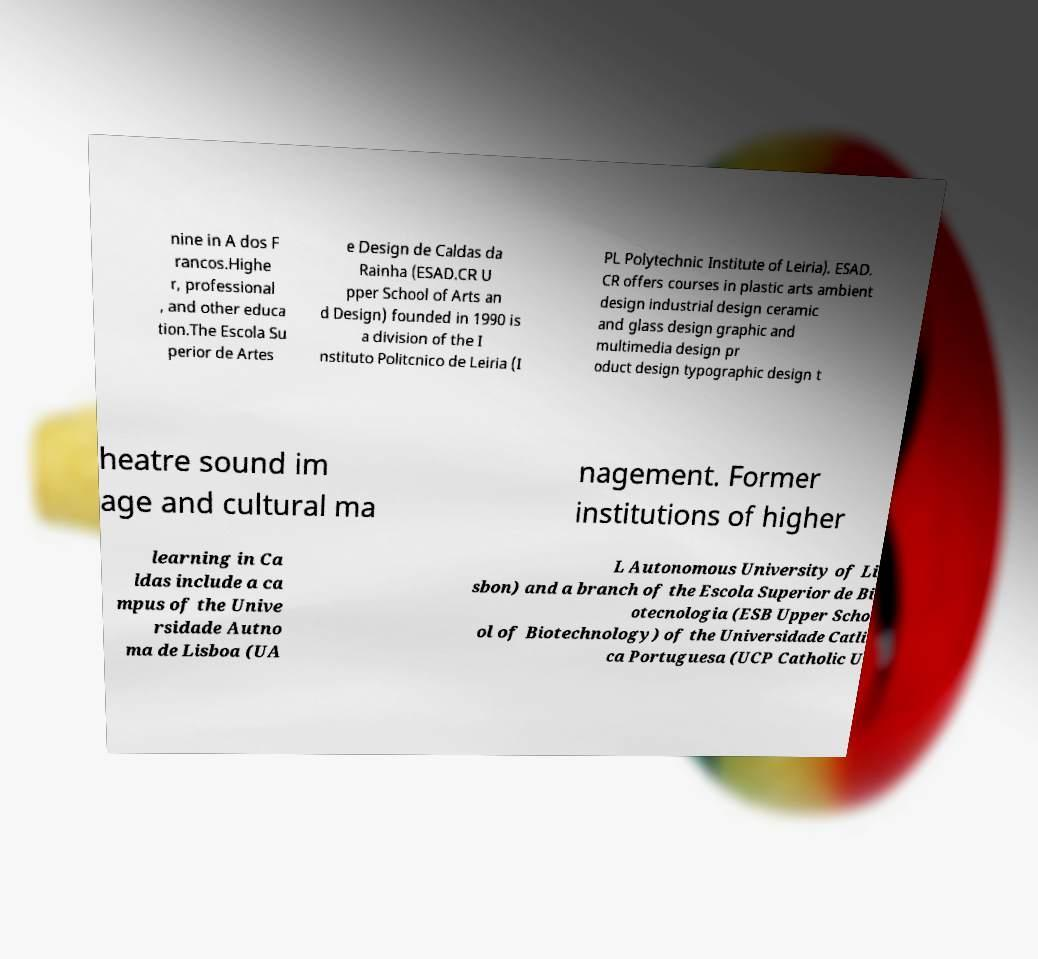Please read and relay the text visible in this image. What does it say? nine in A dos F rancos.Highe r, professional , and other educa tion.The Escola Su perior de Artes e Design de Caldas da Rainha (ESAD.CR U pper School of Arts an d Design) founded in 1990 is a division of the I nstituto Politcnico de Leiria (I PL Polytechnic Institute of Leiria). ESAD. CR offers courses in plastic arts ambient design industrial design ceramic and glass design graphic and multimedia design pr oduct design typographic design t heatre sound im age and cultural ma nagement. Former institutions of higher learning in Ca ldas include a ca mpus of the Unive rsidade Autno ma de Lisboa (UA L Autonomous University of Li sbon) and a branch of the Escola Superior de Bi otecnologia (ESB Upper Scho ol of Biotechnology) of the Universidade Catli ca Portuguesa (UCP Catholic U 